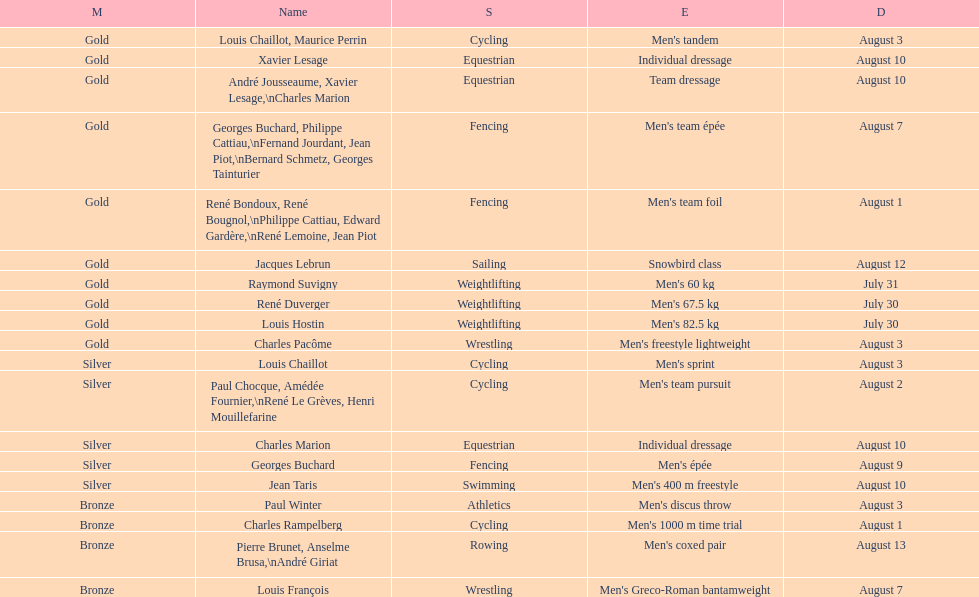How many gold awards were won by this country in these olympics? 10. 